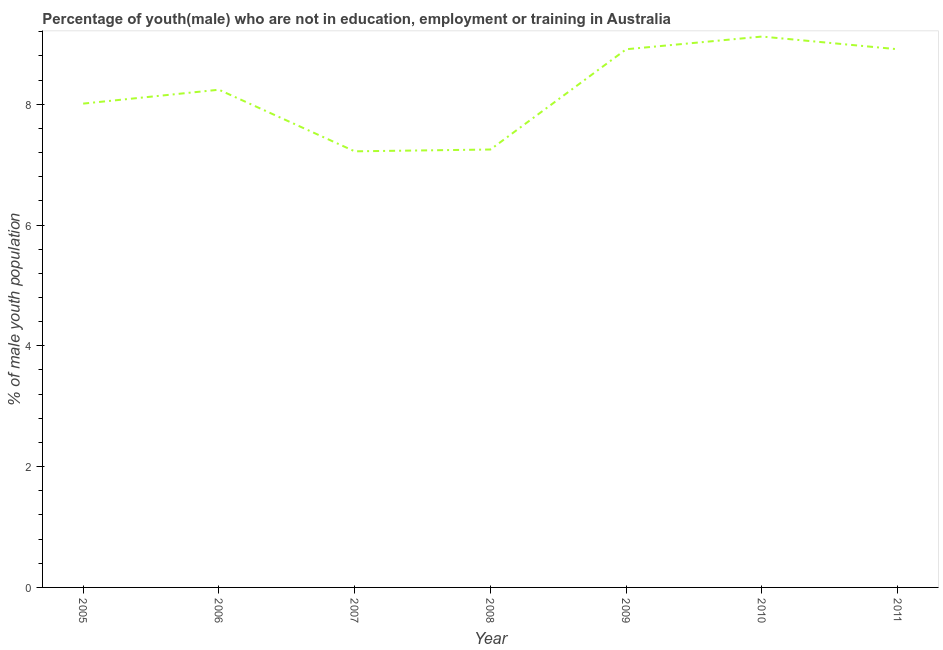What is the unemployed male youth population in 2009?
Your response must be concise. 8.91. Across all years, what is the maximum unemployed male youth population?
Provide a short and direct response. 9.12. Across all years, what is the minimum unemployed male youth population?
Offer a very short reply. 7.22. In which year was the unemployed male youth population minimum?
Your answer should be compact. 2007. What is the sum of the unemployed male youth population?
Make the answer very short. 57.66. What is the difference between the unemployed male youth population in 2008 and 2009?
Ensure brevity in your answer.  -1.66. What is the average unemployed male youth population per year?
Keep it short and to the point. 8.24. What is the median unemployed male youth population?
Keep it short and to the point. 8.24. In how many years, is the unemployed male youth population greater than 2 %?
Ensure brevity in your answer.  7. What is the ratio of the unemployed male youth population in 2006 to that in 2007?
Ensure brevity in your answer.  1.14. What is the difference between the highest and the second highest unemployed male youth population?
Ensure brevity in your answer.  0.21. What is the difference between the highest and the lowest unemployed male youth population?
Provide a succinct answer. 1.9. In how many years, is the unemployed male youth population greater than the average unemployed male youth population taken over all years?
Provide a succinct answer. 4. Does the unemployed male youth population monotonically increase over the years?
Your answer should be very brief. No. What is the title of the graph?
Your answer should be compact. Percentage of youth(male) who are not in education, employment or training in Australia. What is the label or title of the X-axis?
Your response must be concise. Year. What is the label or title of the Y-axis?
Provide a succinct answer. % of male youth population. What is the % of male youth population of 2005?
Provide a succinct answer. 8.01. What is the % of male youth population of 2006?
Your answer should be very brief. 8.24. What is the % of male youth population of 2007?
Provide a succinct answer. 7.22. What is the % of male youth population in 2008?
Provide a short and direct response. 7.25. What is the % of male youth population of 2009?
Offer a very short reply. 8.91. What is the % of male youth population of 2010?
Offer a very short reply. 9.12. What is the % of male youth population of 2011?
Ensure brevity in your answer.  8.91. What is the difference between the % of male youth population in 2005 and 2006?
Ensure brevity in your answer.  -0.23. What is the difference between the % of male youth population in 2005 and 2007?
Your answer should be very brief. 0.79. What is the difference between the % of male youth population in 2005 and 2008?
Give a very brief answer. 0.76. What is the difference between the % of male youth population in 2005 and 2009?
Provide a short and direct response. -0.9. What is the difference between the % of male youth population in 2005 and 2010?
Keep it short and to the point. -1.11. What is the difference between the % of male youth population in 2005 and 2011?
Offer a very short reply. -0.9. What is the difference between the % of male youth population in 2006 and 2007?
Give a very brief answer. 1.02. What is the difference between the % of male youth population in 2006 and 2009?
Provide a succinct answer. -0.67. What is the difference between the % of male youth population in 2006 and 2010?
Your response must be concise. -0.88. What is the difference between the % of male youth population in 2006 and 2011?
Offer a very short reply. -0.67. What is the difference between the % of male youth population in 2007 and 2008?
Make the answer very short. -0.03. What is the difference between the % of male youth population in 2007 and 2009?
Give a very brief answer. -1.69. What is the difference between the % of male youth population in 2007 and 2011?
Make the answer very short. -1.69. What is the difference between the % of male youth population in 2008 and 2009?
Make the answer very short. -1.66. What is the difference between the % of male youth population in 2008 and 2010?
Offer a very short reply. -1.87. What is the difference between the % of male youth population in 2008 and 2011?
Offer a very short reply. -1.66. What is the difference between the % of male youth population in 2009 and 2010?
Keep it short and to the point. -0.21. What is the difference between the % of male youth population in 2010 and 2011?
Your answer should be compact. 0.21. What is the ratio of the % of male youth population in 2005 to that in 2006?
Provide a succinct answer. 0.97. What is the ratio of the % of male youth population in 2005 to that in 2007?
Keep it short and to the point. 1.11. What is the ratio of the % of male youth population in 2005 to that in 2008?
Provide a succinct answer. 1.1. What is the ratio of the % of male youth population in 2005 to that in 2009?
Your answer should be very brief. 0.9. What is the ratio of the % of male youth population in 2005 to that in 2010?
Offer a terse response. 0.88. What is the ratio of the % of male youth population in 2005 to that in 2011?
Ensure brevity in your answer.  0.9. What is the ratio of the % of male youth population in 2006 to that in 2007?
Ensure brevity in your answer.  1.14. What is the ratio of the % of male youth population in 2006 to that in 2008?
Provide a succinct answer. 1.14. What is the ratio of the % of male youth population in 2006 to that in 2009?
Make the answer very short. 0.93. What is the ratio of the % of male youth population in 2006 to that in 2010?
Offer a very short reply. 0.9. What is the ratio of the % of male youth population in 2006 to that in 2011?
Make the answer very short. 0.93. What is the ratio of the % of male youth population in 2007 to that in 2008?
Your response must be concise. 1. What is the ratio of the % of male youth population in 2007 to that in 2009?
Provide a succinct answer. 0.81. What is the ratio of the % of male youth population in 2007 to that in 2010?
Offer a terse response. 0.79. What is the ratio of the % of male youth population in 2007 to that in 2011?
Offer a terse response. 0.81. What is the ratio of the % of male youth population in 2008 to that in 2009?
Provide a short and direct response. 0.81. What is the ratio of the % of male youth population in 2008 to that in 2010?
Give a very brief answer. 0.8. What is the ratio of the % of male youth population in 2008 to that in 2011?
Your answer should be compact. 0.81. What is the ratio of the % of male youth population in 2009 to that in 2010?
Your answer should be very brief. 0.98. What is the ratio of the % of male youth population in 2009 to that in 2011?
Ensure brevity in your answer.  1. 